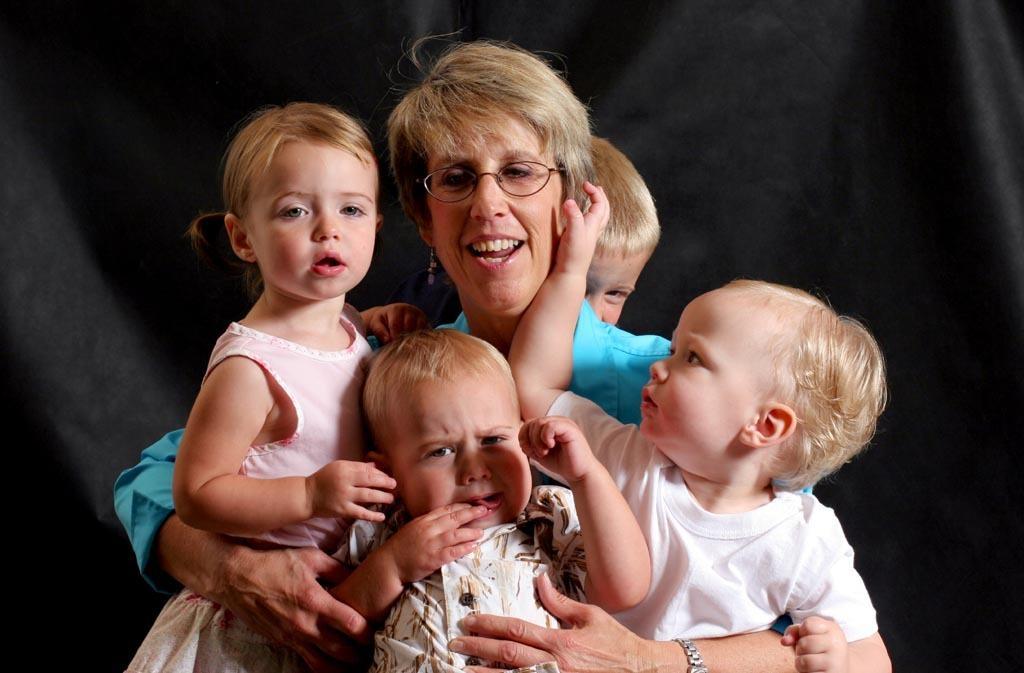How would you summarize this image in a sentence or two? In the middle of this image, there is a woman in a blue color t-shirt, holding three babies and smiling. Behind her, there is another baby. And the background is dark in color. 